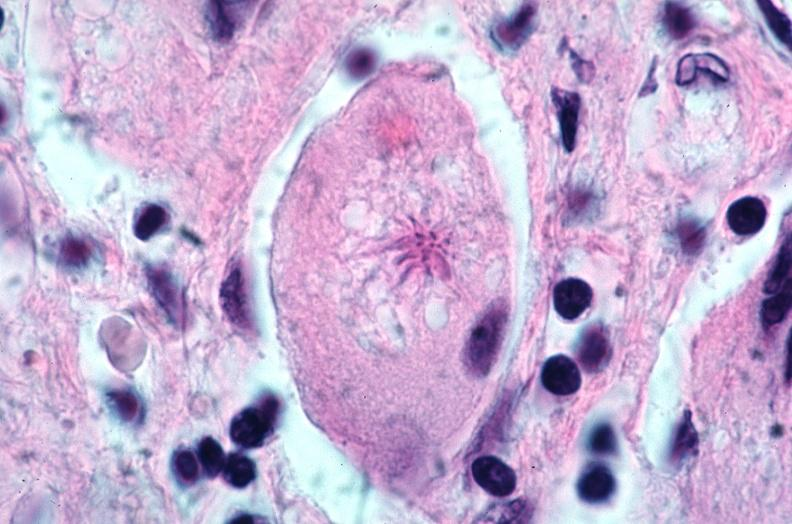what is present?
Answer the question using a single word or phrase. Respiratory 